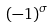<formula> <loc_0><loc_0><loc_500><loc_500>( - 1 ) ^ { \sigma }</formula> 